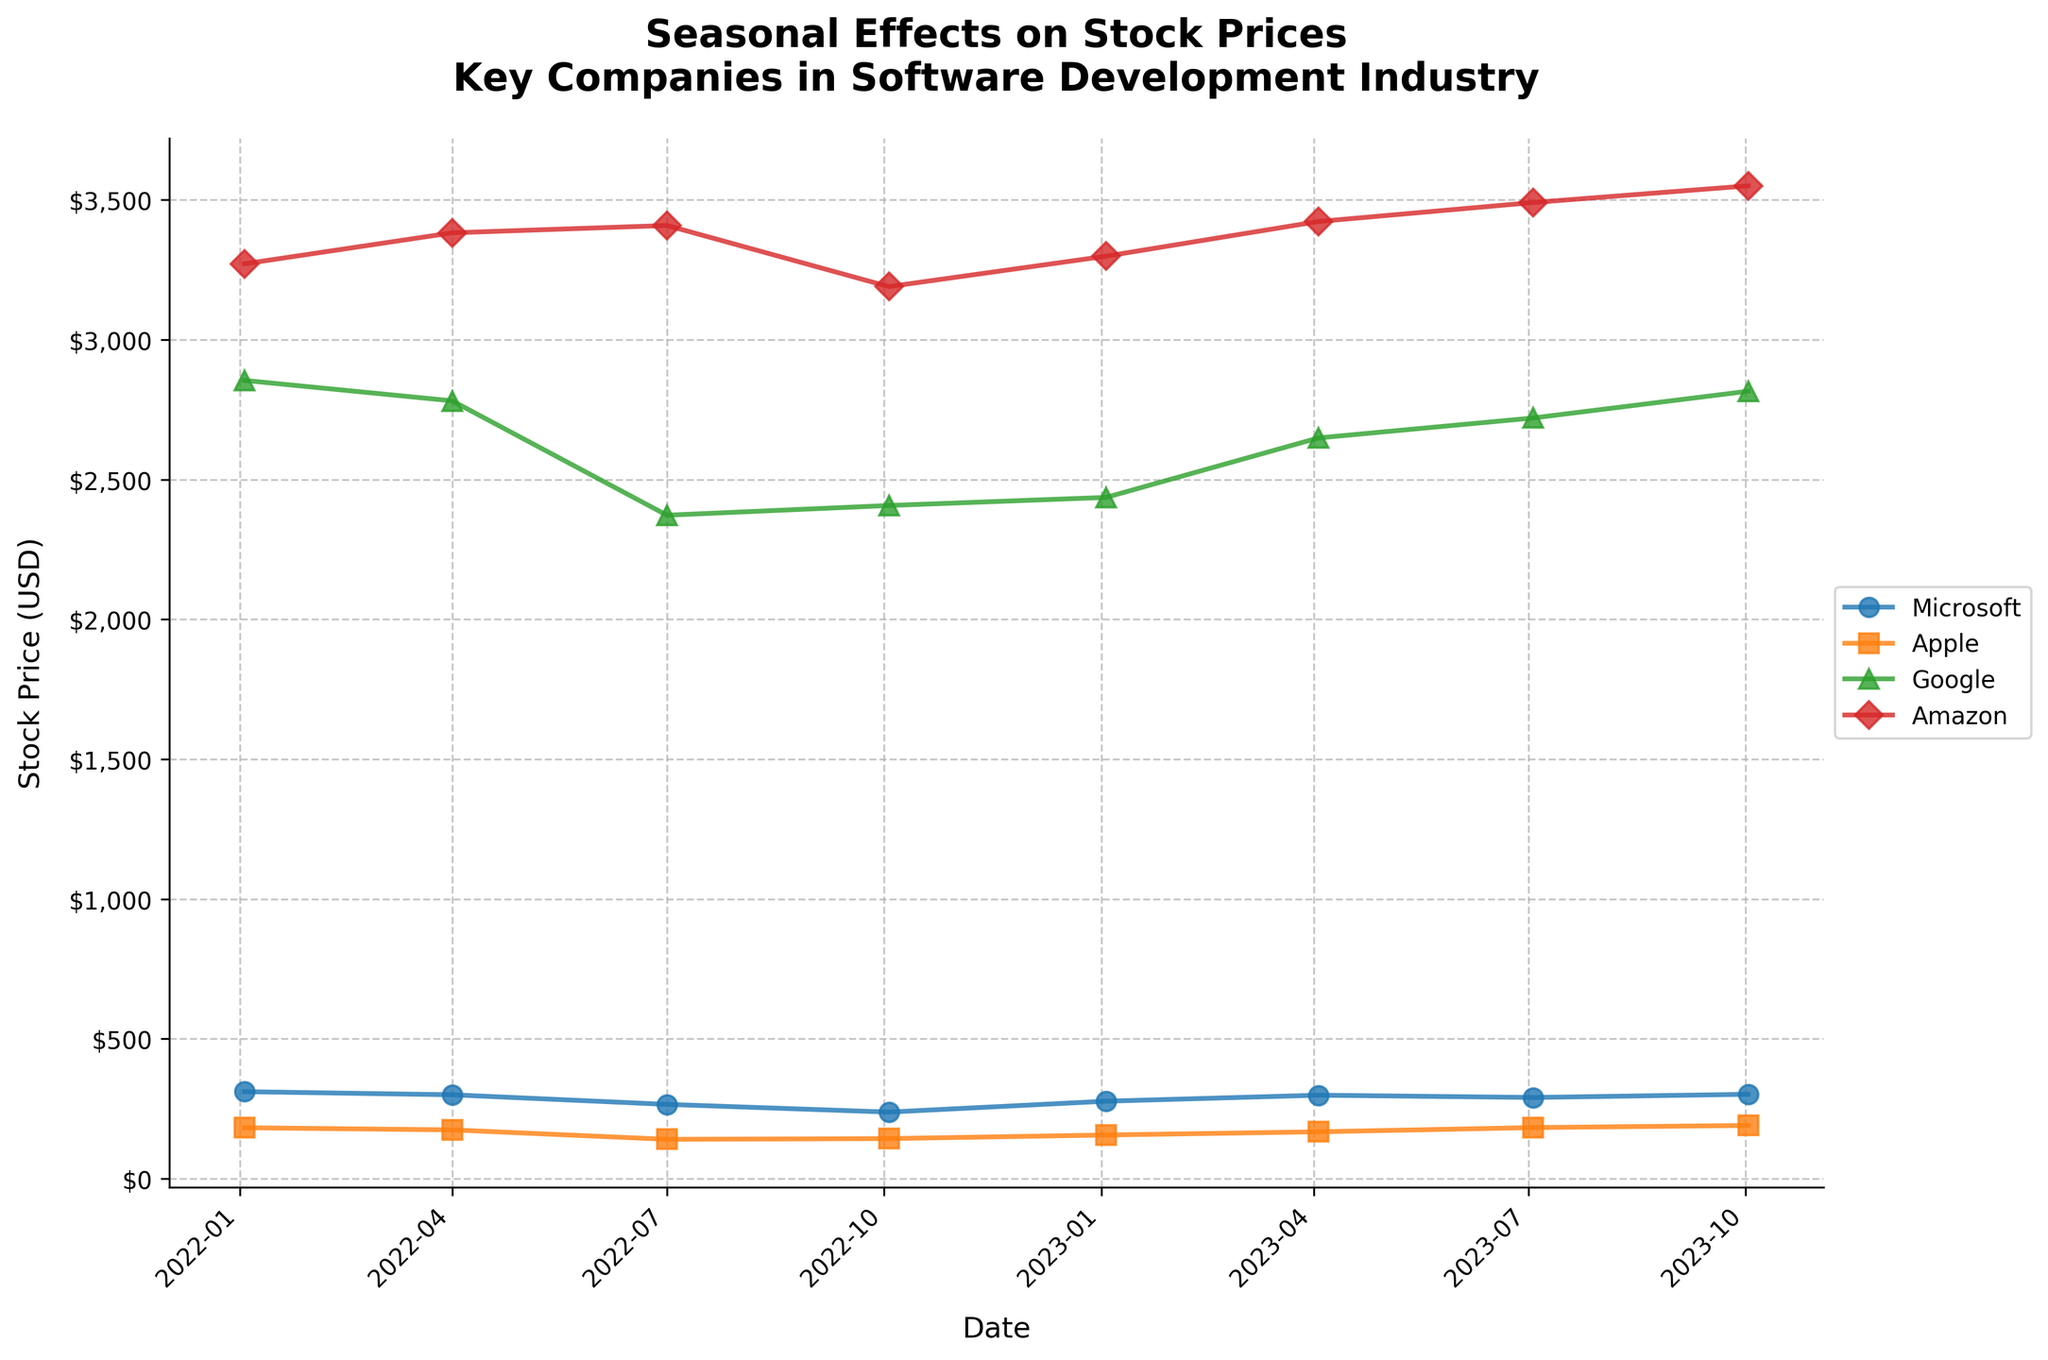What's the title of the plot? The title of the plot is the text displayed at the top, summarizing what the plot represents.
Answer: Seasonal Effects on Stock Prices\nKey Companies in Software Development Industry What's the date range covered by the plot? Dates can be seen along the x-axis, showing the earliest and latest dates for which data points are plotted.
Answer: 2022-01-03 to 2023-10-02 How many companies are included in the plot? Each unique color and marker combination represents a different company according to the legend.
Answer: 4 Which company had the lowest stock price in July 2022? Find the plotted points for each company in July 2022 and identify the one with the lowest y-axis value.
Answer: Apple What's the highest stock price Amazon achieved according to the plot? Compare all the plotted points for Amazon and locate the maximum y-axis value.
Answer: 3550.18 Which company showed the most consistent increase in stock price from January 2022 to October 2023? Compare the trend of the lines for each company and determine which line shows a steady upward trajectory.
Answer: Apple Between January 2023 and July 2023, which company had the greatest increase in stock price? Calculate the difference in stock prices for each company between these dates and identify the largest increase.
Answer: Apple Does Google stock price show any seasonal pattern? Observe the trend of Google's plotted points across different times of the year to identify any recurring patterns.
Answer: No clear seasonal pattern What was the difference in stock price for Microsoft between January 2022 and October 2023? Subtract the stock price of Microsoft on January 2022 from its stock price on October 2023.
Answer: 301.57 - 310.95 = -9.38 Which company had the greatest fluctuation in stock prices throughout the period? Determine the range (difference between maximum and minimum values) for each company's stock prices and find the largest range.
Answer: Amazon 